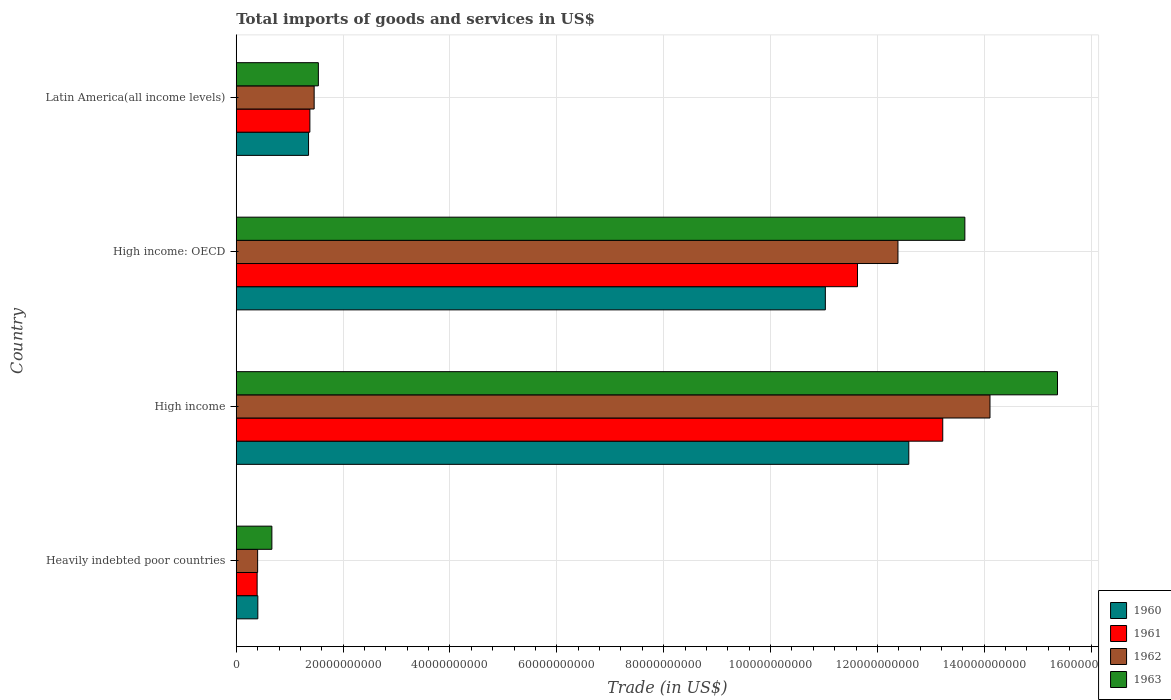How many different coloured bars are there?
Your answer should be very brief. 4. How many groups of bars are there?
Offer a very short reply. 4. Are the number of bars per tick equal to the number of legend labels?
Your response must be concise. Yes. Are the number of bars on each tick of the Y-axis equal?
Keep it short and to the point. Yes. What is the label of the 2nd group of bars from the top?
Give a very brief answer. High income: OECD. In how many cases, is the number of bars for a given country not equal to the number of legend labels?
Your answer should be very brief. 0. What is the total imports of goods and services in 1963 in Heavily indebted poor countries?
Offer a terse response. 6.67e+09. Across all countries, what is the maximum total imports of goods and services in 1960?
Your answer should be very brief. 1.26e+11. Across all countries, what is the minimum total imports of goods and services in 1963?
Keep it short and to the point. 6.67e+09. In which country was the total imports of goods and services in 1960 maximum?
Your response must be concise. High income. In which country was the total imports of goods and services in 1960 minimum?
Provide a succinct answer. Heavily indebted poor countries. What is the total total imports of goods and services in 1961 in the graph?
Your answer should be compact. 2.66e+11. What is the difference between the total imports of goods and services in 1962 in Heavily indebted poor countries and that in Latin America(all income levels)?
Your answer should be compact. -1.06e+1. What is the difference between the total imports of goods and services in 1963 in Heavily indebted poor countries and the total imports of goods and services in 1961 in High income: OECD?
Your answer should be compact. -1.10e+11. What is the average total imports of goods and services in 1962 per country?
Your response must be concise. 7.09e+1. What is the difference between the total imports of goods and services in 1960 and total imports of goods and services in 1963 in Latin America(all income levels)?
Your answer should be compact. -1.83e+09. What is the ratio of the total imports of goods and services in 1962 in High income to that in High income: OECD?
Provide a short and direct response. 1.14. What is the difference between the highest and the second highest total imports of goods and services in 1961?
Ensure brevity in your answer.  1.60e+1. What is the difference between the highest and the lowest total imports of goods and services in 1960?
Your response must be concise. 1.22e+11. In how many countries, is the total imports of goods and services in 1962 greater than the average total imports of goods and services in 1962 taken over all countries?
Provide a short and direct response. 2. Is it the case that in every country, the sum of the total imports of goods and services in 1962 and total imports of goods and services in 1960 is greater than the sum of total imports of goods and services in 1963 and total imports of goods and services in 1961?
Provide a succinct answer. No. What does the 3rd bar from the bottom in Latin America(all income levels) represents?
Give a very brief answer. 1962. Is it the case that in every country, the sum of the total imports of goods and services in 1962 and total imports of goods and services in 1961 is greater than the total imports of goods and services in 1960?
Offer a terse response. Yes. How many countries are there in the graph?
Provide a succinct answer. 4. Does the graph contain any zero values?
Offer a terse response. No. Where does the legend appear in the graph?
Provide a short and direct response. Bottom right. How many legend labels are there?
Make the answer very short. 4. What is the title of the graph?
Keep it short and to the point. Total imports of goods and services in US$. What is the label or title of the X-axis?
Ensure brevity in your answer.  Trade (in US$). What is the label or title of the Y-axis?
Ensure brevity in your answer.  Country. What is the Trade (in US$) in 1960 in Heavily indebted poor countries?
Your answer should be compact. 4.04e+09. What is the Trade (in US$) in 1961 in Heavily indebted poor countries?
Keep it short and to the point. 3.91e+09. What is the Trade (in US$) of 1962 in Heavily indebted poor countries?
Your response must be concise. 4.00e+09. What is the Trade (in US$) of 1963 in Heavily indebted poor countries?
Provide a short and direct response. 6.67e+09. What is the Trade (in US$) of 1960 in High income?
Your response must be concise. 1.26e+11. What is the Trade (in US$) in 1961 in High income?
Keep it short and to the point. 1.32e+11. What is the Trade (in US$) of 1962 in High income?
Offer a very short reply. 1.41e+11. What is the Trade (in US$) of 1963 in High income?
Provide a short and direct response. 1.54e+11. What is the Trade (in US$) in 1960 in High income: OECD?
Your response must be concise. 1.10e+11. What is the Trade (in US$) of 1961 in High income: OECD?
Your answer should be very brief. 1.16e+11. What is the Trade (in US$) of 1962 in High income: OECD?
Make the answer very short. 1.24e+11. What is the Trade (in US$) of 1963 in High income: OECD?
Ensure brevity in your answer.  1.36e+11. What is the Trade (in US$) in 1960 in Latin America(all income levels)?
Give a very brief answer. 1.35e+1. What is the Trade (in US$) in 1961 in Latin America(all income levels)?
Your response must be concise. 1.38e+1. What is the Trade (in US$) of 1962 in Latin America(all income levels)?
Keep it short and to the point. 1.46e+1. What is the Trade (in US$) of 1963 in Latin America(all income levels)?
Keep it short and to the point. 1.54e+1. Across all countries, what is the maximum Trade (in US$) of 1960?
Your response must be concise. 1.26e+11. Across all countries, what is the maximum Trade (in US$) in 1961?
Your response must be concise. 1.32e+11. Across all countries, what is the maximum Trade (in US$) of 1962?
Keep it short and to the point. 1.41e+11. Across all countries, what is the maximum Trade (in US$) in 1963?
Your response must be concise. 1.54e+11. Across all countries, what is the minimum Trade (in US$) in 1960?
Ensure brevity in your answer.  4.04e+09. Across all countries, what is the minimum Trade (in US$) in 1961?
Give a very brief answer. 3.91e+09. Across all countries, what is the minimum Trade (in US$) of 1962?
Provide a succinct answer. 4.00e+09. Across all countries, what is the minimum Trade (in US$) in 1963?
Offer a very short reply. 6.67e+09. What is the total Trade (in US$) of 1960 in the graph?
Provide a short and direct response. 2.54e+11. What is the total Trade (in US$) in 1961 in the graph?
Give a very brief answer. 2.66e+11. What is the total Trade (in US$) in 1962 in the graph?
Make the answer very short. 2.84e+11. What is the total Trade (in US$) of 1963 in the graph?
Offer a very short reply. 3.12e+11. What is the difference between the Trade (in US$) of 1960 in Heavily indebted poor countries and that in High income?
Ensure brevity in your answer.  -1.22e+11. What is the difference between the Trade (in US$) in 1961 in Heavily indebted poor countries and that in High income?
Offer a terse response. -1.28e+11. What is the difference between the Trade (in US$) of 1962 in Heavily indebted poor countries and that in High income?
Your answer should be very brief. -1.37e+11. What is the difference between the Trade (in US$) in 1963 in Heavily indebted poor countries and that in High income?
Make the answer very short. -1.47e+11. What is the difference between the Trade (in US$) in 1960 in Heavily indebted poor countries and that in High income: OECD?
Your answer should be very brief. -1.06e+11. What is the difference between the Trade (in US$) in 1961 in Heavily indebted poor countries and that in High income: OECD?
Offer a very short reply. -1.12e+11. What is the difference between the Trade (in US$) of 1962 in Heavily indebted poor countries and that in High income: OECD?
Ensure brevity in your answer.  -1.20e+11. What is the difference between the Trade (in US$) of 1963 in Heavily indebted poor countries and that in High income: OECD?
Provide a succinct answer. -1.30e+11. What is the difference between the Trade (in US$) in 1960 in Heavily indebted poor countries and that in Latin America(all income levels)?
Your response must be concise. -9.49e+09. What is the difference between the Trade (in US$) in 1961 in Heavily indebted poor countries and that in Latin America(all income levels)?
Give a very brief answer. -9.87e+09. What is the difference between the Trade (in US$) of 1962 in Heavily indebted poor countries and that in Latin America(all income levels)?
Provide a succinct answer. -1.06e+1. What is the difference between the Trade (in US$) of 1963 in Heavily indebted poor countries and that in Latin America(all income levels)?
Keep it short and to the point. -8.70e+09. What is the difference between the Trade (in US$) in 1960 in High income and that in High income: OECD?
Your answer should be very brief. 1.56e+1. What is the difference between the Trade (in US$) in 1961 in High income and that in High income: OECD?
Keep it short and to the point. 1.60e+1. What is the difference between the Trade (in US$) of 1962 in High income and that in High income: OECD?
Give a very brief answer. 1.72e+1. What is the difference between the Trade (in US$) in 1963 in High income and that in High income: OECD?
Your answer should be compact. 1.73e+1. What is the difference between the Trade (in US$) of 1960 in High income and that in Latin America(all income levels)?
Offer a very short reply. 1.12e+11. What is the difference between the Trade (in US$) of 1961 in High income and that in Latin America(all income levels)?
Your response must be concise. 1.18e+11. What is the difference between the Trade (in US$) of 1962 in High income and that in Latin America(all income levels)?
Offer a terse response. 1.26e+11. What is the difference between the Trade (in US$) of 1963 in High income and that in Latin America(all income levels)?
Provide a short and direct response. 1.38e+11. What is the difference between the Trade (in US$) in 1960 in High income: OECD and that in Latin America(all income levels)?
Provide a succinct answer. 9.67e+1. What is the difference between the Trade (in US$) in 1961 in High income: OECD and that in Latin America(all income levels)?
Your answer should be compact. 1.02e+11. What is the difference between the Trade (in US$) in 1962 in High income: OECD and that in Latin America(all income levels)?
Offer a very short reply. 1.09e+11. What is the difference between the Trade (in US$) in 1963 in High income: OECD and that in Latin America(all income levels)?
Your response must be concise. 1.21e+11. What is the difference between the Trade (in US$) in 1960 in Heavily indebted poor countries and the Trade (in US$) in 1961 in High income?
Ensure brevity in your answer.  -1.28e+11. What is the difference between the Trade (in US$) in 1960 in Heavily indebted poor countries and the Trade (in US$) in 1962 in High income?
Offer a terse response. -1.37e+11. What is the difference between the Trade (in US$) of 1960 in Heavily indebted poor countries and the Trade (in US$) of 1963 in High income?
Provide a short and direct response. -1.50e+11. What is the difference between the Trade (in US$) in 1961 in Heavily indebted poor countries and the Trade (in US$) in 1962 in High income?
Keep it short and to the point. -1.37e+11. What is the difference between the Trade (in US$) in 1961 in Heavily indebted poor countries and the Trade (in US$) in 1963 in High income?
Make the answer very short. -1.50e+11. What is the difference between the Trade (in US$) in 1962 in Heavily indebted poor countries and the Trade (in US$) in 1963 in High income?
Keep it short and to the point. -1.50e+11. What is the difference between the Trade (in US$) in 1960 in Heavily indebted poor countries and the Trade (in US$) in 1961 in High income: OECD?
Give a very brief answer. -1.12e+11. What is the difference between the Trade (in US$) of 1960 in Heavily indebted poor countries and the Trade (in US$) of 1962 in High income: OECD?
Ensure brevity in your answer.  -1.20e+11. What is the difference between the Trade (in US$) of 1960 in Heavily indebted poor countries and the Trade (in US$) of 1963 in High income: OECD?
Offer a terse response. -1.32e+11. What is the difference between the Trade (in US$) in 1961 in Heavily indebted poor countries and the Trade (in US$) in 1962 in High income: OECD?
Offer a terse response. -1.20e+11. What is the difference between the Trade (in US$) of 1961 in Heavily indebted poor countries and the Trade (in US$) of 1963 in High income: OECD?
Your answer should be compact. -1.32e+11. What is the difference between the Trade (in US$) of 1962 in Heavily indebted poor countries and the Trade (in US$) of 1963 in High income: OECD?
Offer a very short reply. -1.32e+11. What is the difference between the Trade (in US$) of 1960 in Heavily indebted poor countries and the Trade (in US$) of 1961 in Latin America(all income levels)?
Keep it short and to the point. -9.74e+09. What is the difference between the Trade (in US$) of 1960 in Heavily indebted poor countries and the Trade (in US$) of 1962 in Latin America(all income levels)?
Your response must be concise. -1.05e+1. What is the difference between the Trade (in US$) of 1960 in Heavily indebted poor countries and the Trade (in US$) of 1963 in Latin America(all income levels)?
Your answer should be very brief. -1.13e+1. What is the difference between the Trade (in US$) of 1961 in Heavily indebted poor countries and the Trade (in US$) of 1962 in Latin America(all income levels)?
Your answer should be compact. -1.07e+1. What is the difference between the Trade (in US$) of 1961 in Heavily indebted poor countries and the Trade (in US$) of 1963 in Latin America(all income levels)?
Offer a terse response. -1.15e+1. What is the difference between the Trade (in US$) in 1962 in Heavily indebted poor countries and the Trade (in US$) in 1963 in Latin America(all income levels)?
Offer a very short reply. -1.14e+1. What is the difference between the Trade (in US$) of 1960 in High income and the Trade (in US$) of 1961 in High income: OECD?
Your answer should be compact. 9.60e+09. What is the difference between the Trade (in US$) of 1960 in High income and the Trade (in US$) of 1962 in High income: OECD?
Your answer should be very brief. 2.03e+09. What is the difference between the Trade (in US$) in 1960 in High income and the Trade (in US$) in 1963 in High income: OECD?
Ensure brevity in your answer.  -1.05e+1. What is the difference between the Trade (in US$) in 1961 in High income and the Trade (in US$) in 1962 in High income: OECD?
Provide a short and direct response. 8.39e+09. What is the difference between the Trade (in US$) in 1961 in High income and the Trade (in US$) in 1963 in High income: OECD?
Give a very brief answer. -4.14e+09. What is the difference between the Trade (in US$) of 1962 in High income and the Trade (in US$) of 1963 in High income: OECD?
Your answer should be compact. 4.70e+09. What is the difference between the Trade (in US$) of 1960 in High income and the Trade (in US$) of 1961 in Latin America(all income levels)?
Offer a very short reply. 1.12e+11. What is the difference between the Trade (in US$) in 1960 in High income and the Trade (in US$) in 1962 in Latin America(all income levels)?
Make the answer very short. 1.11e+11. What is the difference between the Trade (in US$) in 1960 in High income and the Trade (in US$) in 1963 in Latin America(all income levels)?
Offer a terse response. 1.11e+11. What is the difference between the Trade (in US$) of 1961 in High income and the Trade (in US$) of 1962 in Latin America(all income levels)?
Ensure brevity in your answer.  1.18e+11. What is the difference between the Trade (in US$) in 1961 in High income and the Trade (in US$) in 1963 in Latin America(all income levels)?
Make the answer very short. 1.17e+11. What is the difference between the Trade (in US$) in 1962 in High income and the Trade (in US$) in 1963 in Latin America(all income levels)?
Your answer should be compact. 1.26e+11. What is the difference between the Trade (in US$) of 1960 in High income: OECD and the Trade (in US$) of 1961 in Latin America(all income levels)?
Provide a succinct answer. 9.65e+1. What is the difference between the Trade (in US$) of 1960 in High income: OECD and the Trade (in US$) of 1962 in Latin America(all income levels)?
Make the answer very short. 9.57e+1. What is the difference between the Trade (in US$) of 1960 in High income: OECD and the Trade (in US$) of 1963 in Latin America(all income levels)?
Keep it short and to the point. 9.49e+1. What is the difference between the Trade (in US$) in 1961 in High income: OECD and the Trade (in US$) in 1962 in Latin America(all income levels)?
Keep it short and to the point. 1.02e+11. What is the difference between the Trade (in US$) in 1961 in High income: OECD and the Trade (in US$) in 1963 in Latin America(all income levels)?
Keep it short and to the point. 1.01e+11. What is the difference between the Trade (in US$) in 1962 in High income: OECD and the Trade (in US$) in 1963 in Latin America(all income levels)?
Make the answer very short. 1.08e+11. What is the average Trade (in US$) of 1960 per country?
Your response must be concise. 6.34e+1. What is the average Trade (in US$) in 1961 per country?
Ensure brevity in your answer.  6.65e+1. What is the average Trade (in US$) of 1962 per country?
Give a very brief answer. 7.09e+1. What is the average Trade (in US$) of 1963 per country?
Make the answer very short. 7.80e+1. What is the difference between the Trade (in US$) in 1960 and Trade (in US$) in 1961 in Heavily indebted poor countries?
Make the answer very short. 1.30e+08. What is the difference between the Trade (in US$) of 1960 and Trade (in US$) of 1962 in Heavily indebted poor countries?
Your answer should be compact. 3.87e+07. What is the difference between the Trade (in US$) in 1960 and Trade (in US$) in 1963 in Heavily indebted poor countries?
Offer a very short reply. -2.63e+09. What is the difference between the Trade (in US$) of 1961 and Trade (in US$) of 1962 in Heavily indebted poor countries?
Provide a succinct answer. -9.18e+07. What is the difference between the Trade (in US$) in 1961 and Trade (in US$) in 1963 in Heavily indebted poor countries?
Offer a very short reply. -2.76e+09. What is the difference between the Trade (in US$) of 1962 and Trade (in US$) of 1963 in Heavily indebted poor countries?
Offer a very short reply. -2.67e+09. What is the difference between the Trade (in US$) in 1960 and Trade (in US$) in 1961 in High income?
Your response must be concise. -6.36e+09. What is the difference between the Trade (in US$) in 1960 and Trade (in US$) in 1962 in High income?
Offer a terse response. -1.52e+1. What is the difference between the Trade (in US$) of 1960 and Trade (in US$) of 1963 in High income?
Your answer should be very brief. -2.78e+1. What is the difference between the Trade (in US$) of 1961 and Trade (in US$) of 1962 in High income?
Offer a very short reply. -8.84e+09. What is the difference between the Trade (in US$) of 1961 and Trade (in US$) of 1963 in High income?
Your answer should be compact. -2.15e+1. What is the difference between the Trade (in US$) of 1962 and Trade (in US$) of 1963 in High income?
Offer a terse response. -1.26e+1. What is the difference between the Trade (in US$) of 1960 and Trade (in US$) of 1961 in High income: OECD?
Make the answer very short. -6.02e+09. What is the difference between the Trade (in US$) of 1960 and Trade (in US$) of 1962 in High income: OECD?
Your answer should be very brief. -1.36e+1. What is the difference between the Trade (in US$) of 1960 and Trade (in US$) of 1963 in High income: OECD?
Give a very brief answer. -2.61e+1. What is the difference between the Trade (in US$) in 1961 and Trade (in US$) in 1962 in High income: OECD?
Provide a succinct answer. -7.57e+09. What is the difference between the Trade (in US$) of 1961 and Trade (in US$) of 1963 in High income: OECD?
Ensure brevity in your answer.  -2.01e+1. What is the difference between the Trade (in US$) of 1962 and Trade (in US$) of 1963 in High income: OECD?
Offer a very short reply. -1.25e+1. What is the difference between the Trade (in US$) in 1960 and Trade (in US$) in 1961 in Latin America(all income levels)?
Your answer should be compact. -2.48e+08. What is the difference between the Trade (in US$) in 1960 and Trade (in US$) in 1962 in Latin America(all income levels)?
Your answer should be compact. -1.05e+09. What is the difference between the Trade (in US$) of 1960 and Trade (in US$) of 1963 in Latin America(all income levels)?
Offer a very short reply. -1.83e+09. What is the difference between the Trade (in US$) in 1961 and Trade (in US$) in 1962 in Latin America(all income levels)?
Offer a terse response. -7.99e+08. What is the difference between the Trade (in US$) of 1961 and Trade (in US$) of 1963 in Latin America(all income levels)?
Give a very brief answer. -1.59e+09. What is the difference between the Trade (in US$) in 1962 and Trade (in US$) in 1963 in Latin America(all income levels)?
Your answer should be very brief. -7.87e+08. What is the ratio of the Trade (in US$) in 1960 in Heavily indebted poor countries to that in High income?
Make the answer very short. 0.03. What is the ratio of the Trade (in US$) in 1961 in Heavily indebted poor countries to that in High income?
Ensure brevity in your answer.  0.03. What is the ratio of the Trade (in US$) of 1962 in Heavily indebted poor countries to that in High income?
Provide a short and direct response. 0.03. What is the ratio of the Trade (in US$) in 1963 in Heavily indebted poor countries to that in High income?
Provide a succinct answer. 0.04. What is the ratio of the Trade (in US$) of 1960 in Heavily indebted poor countries to that in High income: OECD?
Ensure brevity in your answer.  0.04. What is the ratio of the Trade (in US$) in 1961 in Heavily indebted poor countries to that in High income: OECD?
Provide a succinct answer. 0.03. What is the ratio of the Trade (in US$) of 1962 in Heavily indebted poor countries to that in High income: OECD?
Make the answer very short. 0.03. What is the ratio of the Trade (in US$) of 1963 in Heavily indebted poor countries to that in High income: OECD?
Your answer should be very brief. 0.05. What is the ratio of the Trade (in US$) of 1960 in Heavily indebted poor countries to that in Latin America(all income levels)?
Provide a succinct answer. 0.3. What is the ratio of the Trade (in US$) in 1961 in Heavily indebted poor countries to that in Latin America(all income levels)?
Your response must be concise. 0.28. What is the ratio of the Trade (in US$) in 1962 in Heavily indebted poor countries to that in Latin America(all income levels)?
Provide a short and direct response. 0.27. What is the ratio of the Trade (in US$) of 1963 in Heavily indebted poor countries to that in Latin America(all income levels)?
Ensure brevity in your answer.  0.43. What is the ratio of the Trade (in US$) of 1960 in High income to that in High income: OECD?
Ensure brevity in your answer.  1.14. What is the ratio of the Trade (in US$) in 1961 in High income to that in High income: OECD?
Give a very brief answer. 1.14. What is the ratio of the Trade (in US$) in 1962 in High income to that in High income: OECD?
Keep it short and to the point. 1.14. What is the ratio of the Trade (in US$) in 1963 in High income to that in High income: OECD?
Give a very brief answer. 1.13. What is the ratio of the Trade (in US$) in 1960 in High income to that in Latin America(all income levels)?
Keep it short and to the point. 9.3. What is the ratio of the Trade (in US$) in 1961 in High income to that in Latin America(all income levels)?
Offer a terse response. 9.6. What is the ratio of the Trade (in US$) in 1962 in High income to that in Latin America(all income levels)?
Your answer should be compact. 9.68. What is the ratio of the Trade (in US$) in 1963 in High income to that in Latin America(all income levels)?
Make the answer very short. 10. What is the ratio of the Trade (in US$) in 1960 in High income: OECD to that in Latin America(all income levels)?
Ensure brevity in your answer.  8.15. What is the ratio of the Trade (in US$) of 1961 in High income: OECD to that in Latin America(all income levels)?
Provide a succinct answer. 8.44. What is the ratio of the Trade (in US$) in 1962 in High income: OECD to that in Latin America(all income levels)?
Make the answer very short. 8.49. What is the ratio of the Trade (in US$) of 1963 in High income: OECD to that in Latin America(all income levels)?
Offer a very short reply. 8.87. What is the difference between the highest and the second highest Trade (in US$) in 1960?
Make the answer very short. 1.56e+1. What is the difference between the highest and the second highest Trade (in US$) in 1961?
Offer a very short reply. 1.60e+1. What is the difference between the highest and the second highest Trade (in US$) in 1962?
Offer a very short reply. 1.72e+1. What is the difference between the highest and the second highest Trade (in US$) in 1963?
Offer a terse response. 1.73e+1. What is the difference between the highest and the lowest Trade (in US$) in 1960?
Provide a short and direct response. 1.22e+11. What is the difference between the highest and the lowest Trade (in US$) of 1961?
Ensure brevity in your answer.  1.28e+11. What is the difference between the highest and the lowest Trade (in US$) of 1962?
Offer a terse response. 1.37e+11. What is the difference between the highest and the lowest Trade (in US$) in 1963?
Ensure brevity in your answer.  1.47e+11. 